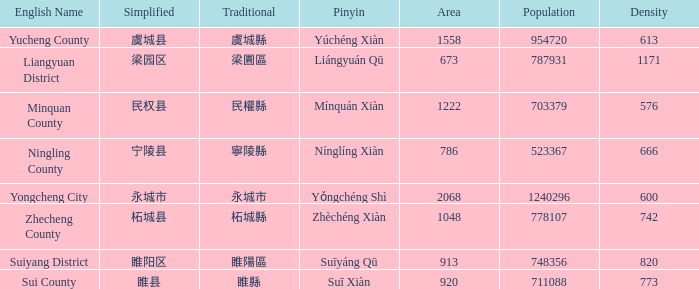What is the traditional form for 宁陵县? 寧陵縣. 